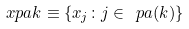Convert formula to latex. <formula><loc_0><loc_0><loc_500><loc_500>\ x p a { k } \equiv \left \{ x _ { j } \colon j \in \ p a ( k ) \right \}</formula> 